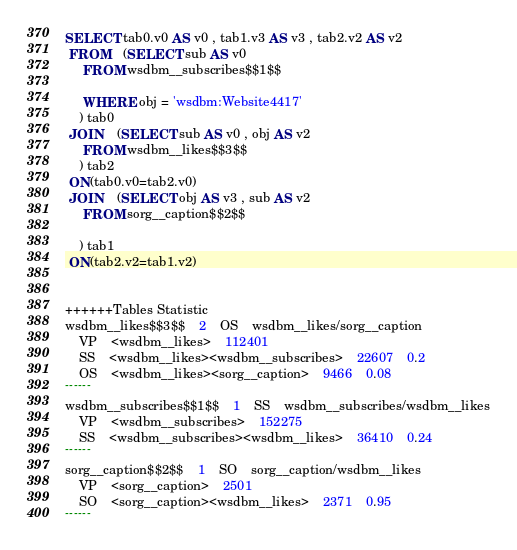Convert code to text. <code><loc_0><loc_0><loc_500><loc_500><_SQL_>SELECT tab0.v0 AS v0 , tab1.v3 AS v3 , tab2.v2 AS v2 
 FROM    (SELECT sub AS v0 
	 FROM wsdbm__subscribes$$1$$
	 
	 WHERE obj = 'wsdbm:Website4417'
	) tab0
 JOIN    (SELECT sub AS v0 , obj AS v2 
	 FROM wsdbm__likes$$3$$
	) tab2
 ON(tab0.v0=tab2.v0)
 JOIN    (SELECT obj AS v3 , sub AS v2 
	 FROM sorg__caption$$2$$
	
	) tab1
 ON(tab2.v2=tab1.v2)


++++++Tables Statistic
wsdbm__likes$$3$$	2	OS	wsdbm__likes/sorg__caption
	VP	<wsdbm__likes>	112401
	SS	<wsdbm__likes><wsdbm__subscribes>	22607	0.2
	OS	<wsdbm__likes><sorg__caption>	9466	0.08
------
wsdbm__subscribes$$1$$	1	SS	wsdbm__subscribes/wsdbm__likes
	VP	<wsdbm__subscribes>	152275
	SS	<wsdbm__subscribes><wsdbm__likes>	36410	0.24
------
sorg__caption$$2$$	1	SO	sorg__caption/wsdbm__likes
	VP	<sorg__caption>	2501
	SO	<sorg__caption><wsdbm__likes>	2371	0.95
------
</code> 